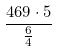Convert formula to latex. <formula><loc_0><loc_0><loc_500><loc_500>\frac { 4 6 9 \cdot 5 } { \frac { 6 } { 4 } }</formula> 